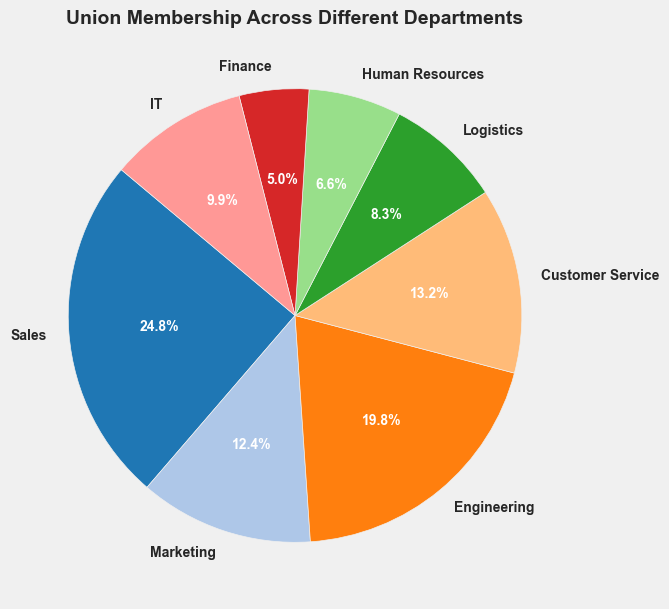What percentage of the union members are from the Sales department? Look at the pie chart segment labeled "Sales" and refer to its percentage, which is displayed directly on the figure.
Answer: 25.9% Which department has the smallest percentage of union members? Identify the smallest pie chart segment and read the department label.
Answer: Finance Compare the union membership between the Engineering and Marketing departments. Which one has more members? Check the size of the pie chart segments for Engineering and Marketing; the larger segment represents the department with more members.
Answer: Engineering What is the combined percentage of union members from Customer Service and Logistics departments? Add the percentages shown on the pie chart for Customer Service and Logistics.
Answer: 13.8% How many more union members are in Sales compared to IT? Subtract the number of union members in IT (60) from the number of union members in Sales (150).
Answer: 90 If you merge the Finance and Human Resources departments, what would be their combined number of union members and their percentage share? Add the union members of Finance (30) and Human Resources (40) to get the combined number (70). Calculate their new percentage over the total (585) by (70/585)*100.
Answer: 12%, 70 members What is the visual color representing the Marketing department in the pie chart? Observe the segment labeled "Marketing" and identify its color from the color palette.
Answer: Blue Rank the departments by their union membership from the highest to lowest. List the departments based on the sizes of their segments, starting from the largest to the smallest.
Answer: Sales, Engineering, Customer Service, IT, Marketing, Logistics, Human Resources, Finance What fraction of the total union membership does IT department constitute? Find the ratio of IT department members (60) to the total union members (585) and simplify it, if possible.
Answer: 2/19 How many departments have a lower union membership than Engineering? Count the pie chart segments that are smaller than the Engineering segment.
Answer: 6 